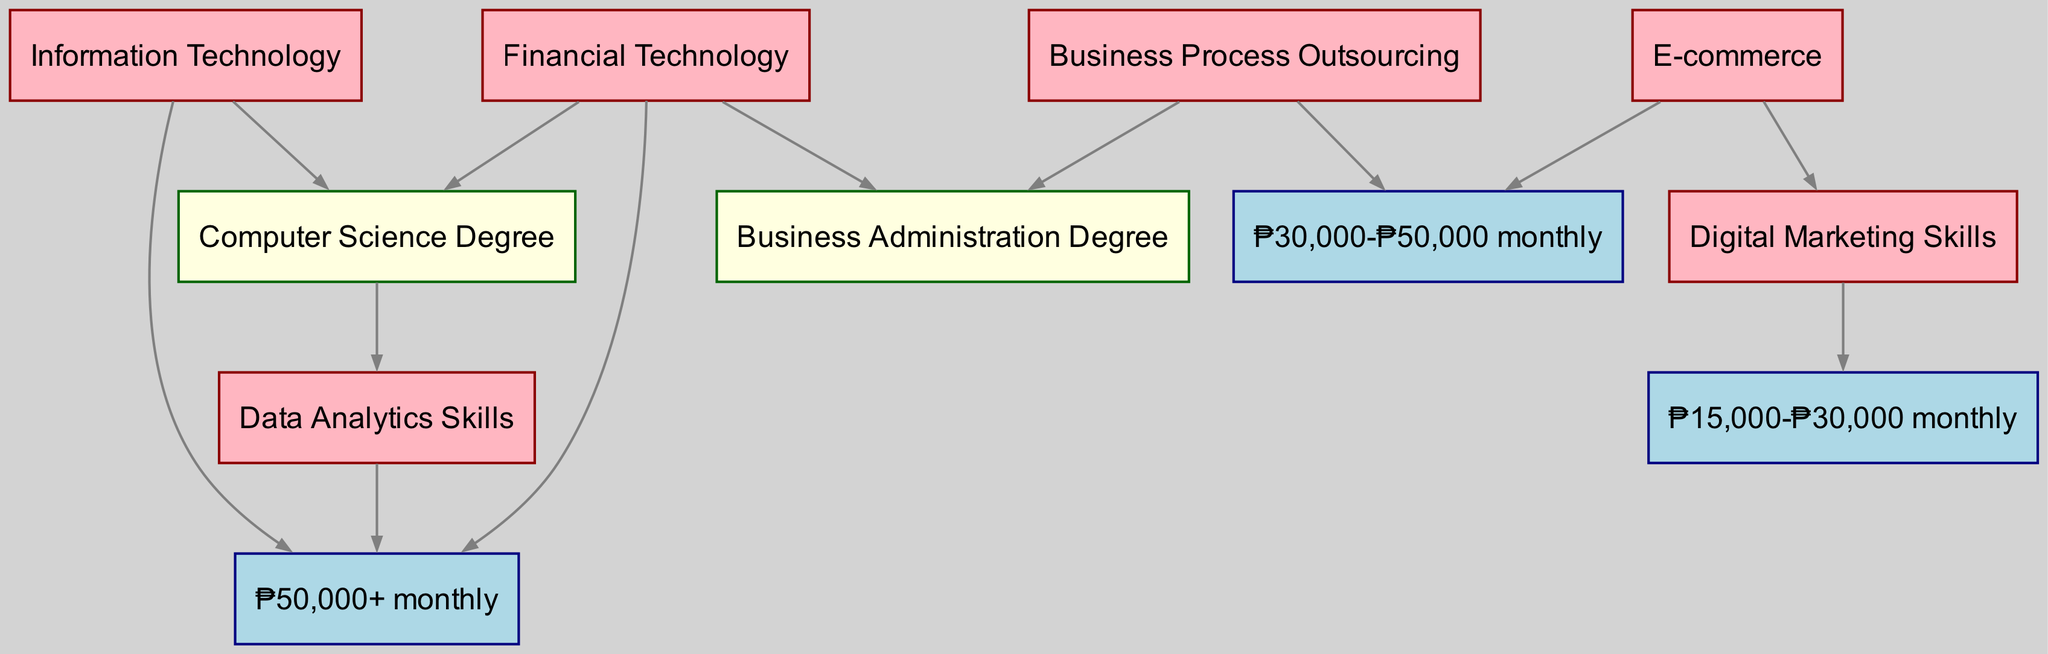What sector is associated with a Computer Science Degree? The directed edge from "IT" to "CS_Degree" indicates that the Information Technology sector is associated with a Computer Science Degree.
Answer: Information Technology What is the highest monthly salary range indicated in the diagram? The edge leading to "High_Salary" from both the "IT" and "FinTech" nodes shows that these sectors are related to the highest monthly salary range, which is ₱50,000+.
Answer: ₱50,000+ Which qualification is needed for the Business Process Outsourcing sector? Observing the directed edge from "BPO" to "Business_Degree" reveals that a Business Administration Degree is required for the Business Process Outsourcing sector.
Answer: Business Administration Degree What sector requires Digital Marketing Skills and corresponds with a lower salary range? The directed edge from "E-commerce" to "Digital_Marketing" shows that the E-commerce sector requires Digital Marketing Skills, and its connection to the "Mid_Salary" node indicates that it corresponds with a lower salary range of ₱30,000-₱50,000 monthly.
Answer: E-commerce How many sectors are connected to the High Salary range? There are directed edges leading to "High_Salary" from "IT," "FinTech," and "Data_Analytics," indicating that three sectors connect to the High Salary range.
Answer: 3 What qualification is related to the Data Analytics skills? The edge from "CS_Degree" to "Data_Analytics" indicates that a Computer Science Degree is related to the Data Analytics skills.
Answer: Computer Science Degree Which salary range is linked with the Digital Marketing skills? The directed edge from "Digital_Marketing" to "Entry_Salary" shows that Digital Marketing skills are linked with the Entry Salary range of ₱15,000-₱30,000 monthly.
Answer: ₱15,000-₱30,000 monthly What role does a Data Analytics skill play in salary discussions in this diagram? The directed edge from "Data_Analytics" to "High_Salary" indicates that possessing Data Analytics skills can lead to a high salary, revealing its importance in salary discussions.
Answer: High Salary Which sector has the lowest associated salary range? Analyzing the directed edges, the "Digital_Marketing" skill links to "Entry_Salary," which is the lowest salary range of ₱15,000-₱30,000 monthly, suggesting that E-commerce has the lowest salary range.
Answer: E-commerce 